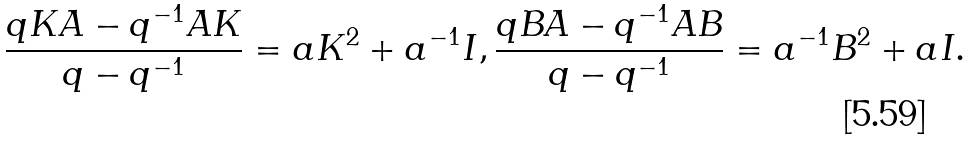Convert formula to latex. <formula><loc_0><loc_0><loc_500><loc_500>& \frac { q K A - q ^ { - 1 } A K } { q - q ^ { - 1 } } = a K ^ { 2 } + a ^ { - 1 } I , \frac { q B A - q ^ { - 1 } A B } { q - q ^ { - 1 } } = a ^ { - 1 } B ^ { 2 } + a I .</formula> 